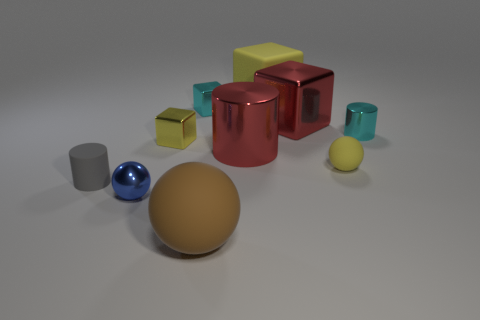Subtract all cylinders. How many objects are left? 7 Add 9 small green matte balls. How many small green matte balls exist? 9 Subtract 0 blue cubes. How many objects are left? 10 Subtract all cyan matte balls. Subtract all large things. How many objects are left? 6 Add 3 gray rubber cylinders. How many gray rubber cylinders are left? 4 